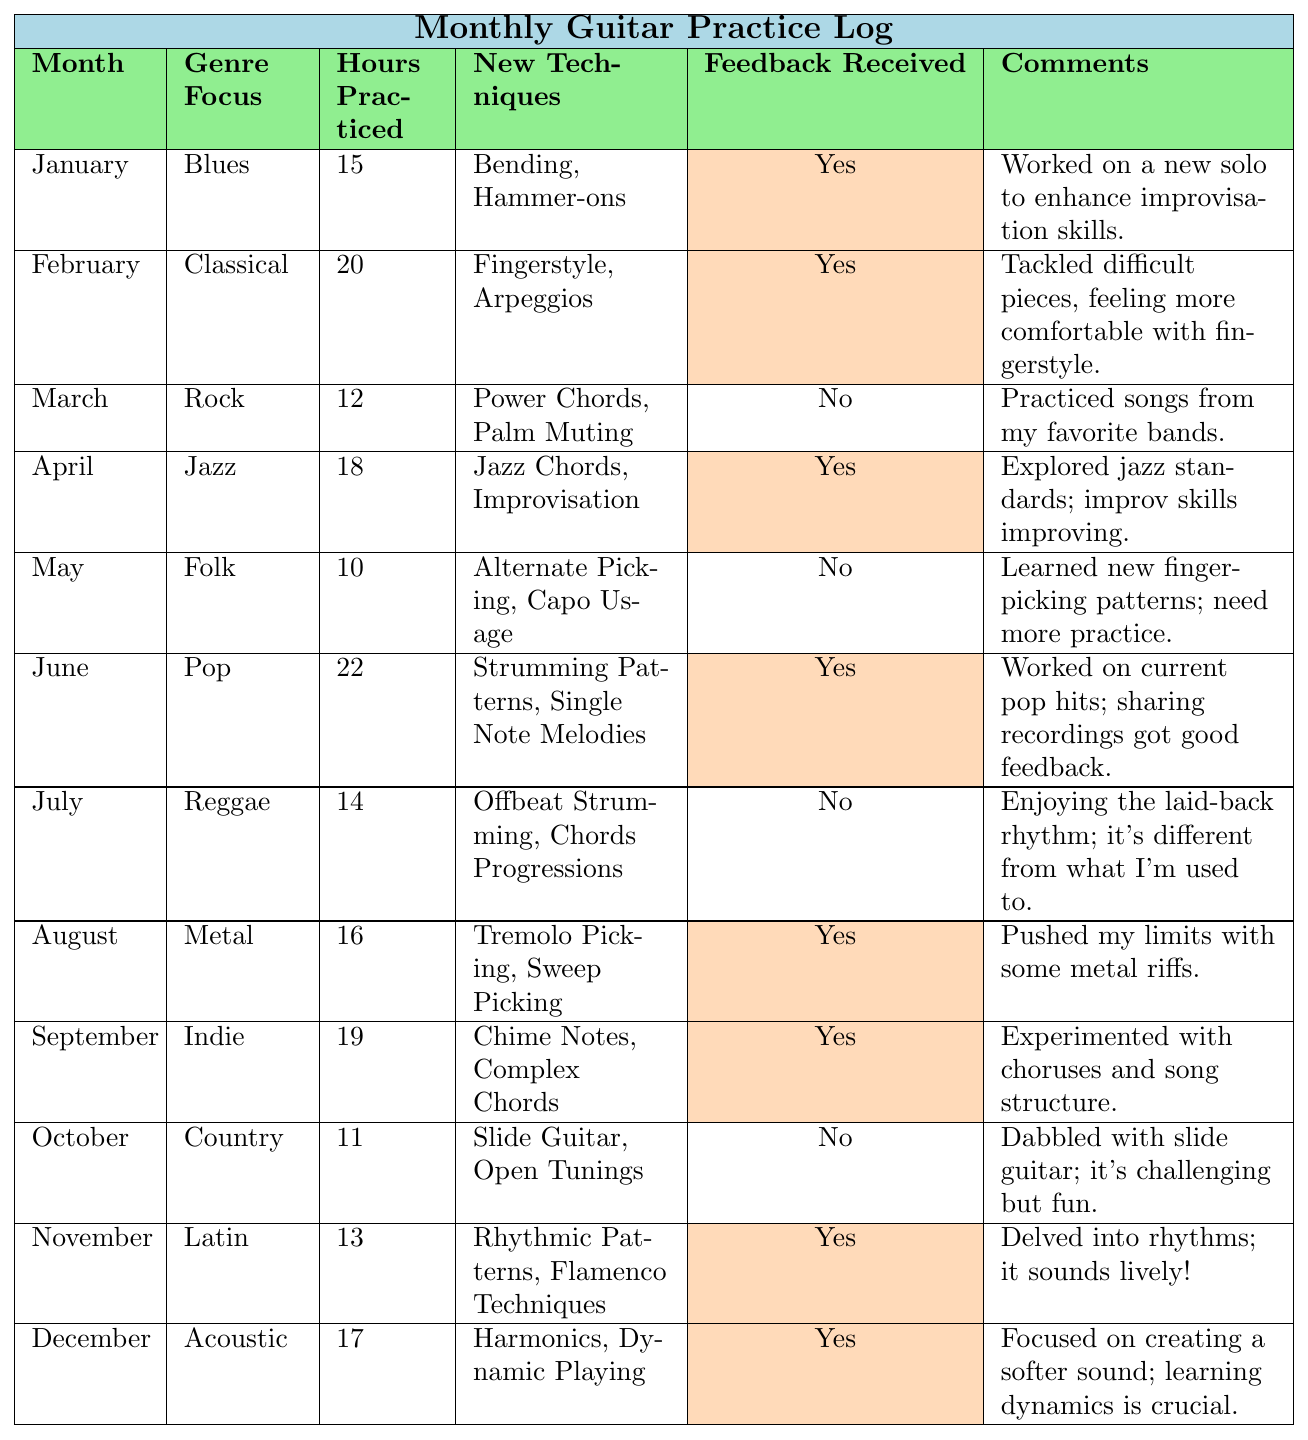What genre did you focus on in June? The table shows that in June, the genre focus was Pop.
Answer: Pop How many hours did you practice in February? Looking at the table, in February the hours practiced were 20.
Answer: 20 Which month did you receive feedback on your recording while focusing on Folk? The table indicates that no feedback was received for the Folk genre in May.
Answer: No feedback received What is the sum of practice hours in January and March? From the table, January has 15 hours and March has 12 hours; adding them together gives 15 + 12 = 27.
Answer: 27 How many months did you practice for more than 15 hours? Referring to the table, the months where hours practiced were more than 15 are February (20), June (22), April (18), September (19), and August (16). Counting these gives 5 months.
Answer: 5 months In which month was the least number of hours practiced? The table shows the lowest hours practiced was in May with 10 hours.
Answer: May Did you receive feedback for your recording in October? The table indicates that no feedback was received for the month of October.
Answer: No What was the average number of hours practiced over the year? To find the average, sum the hours from all months: (15 + 20 + 12 + 18 + 10 + 22 + 14 + 16 + 19 + 11 + 13 + 17) =  15 + 20 + 12 + 18 + 10 + 22 + 14 + 16 + 19 + 11 + 13 + 17 =  17. Take the sum (total  12 months =  12) =  17 / 12 = 16.5  hours per month.
Answer: 16.5 How many new techniques did you learn in total? By counting all the distinct techniques from each month in the table: 2 + 2 + 2 + 2 + 2 + 2 + 2 + 2 + 2 + 2 + 2 + 2 = 24.
Answer: 24 Which genre had the highest total hours of practice? From the table, Pop had the highest total hours with 22 hours in June.
Answer: Pop 